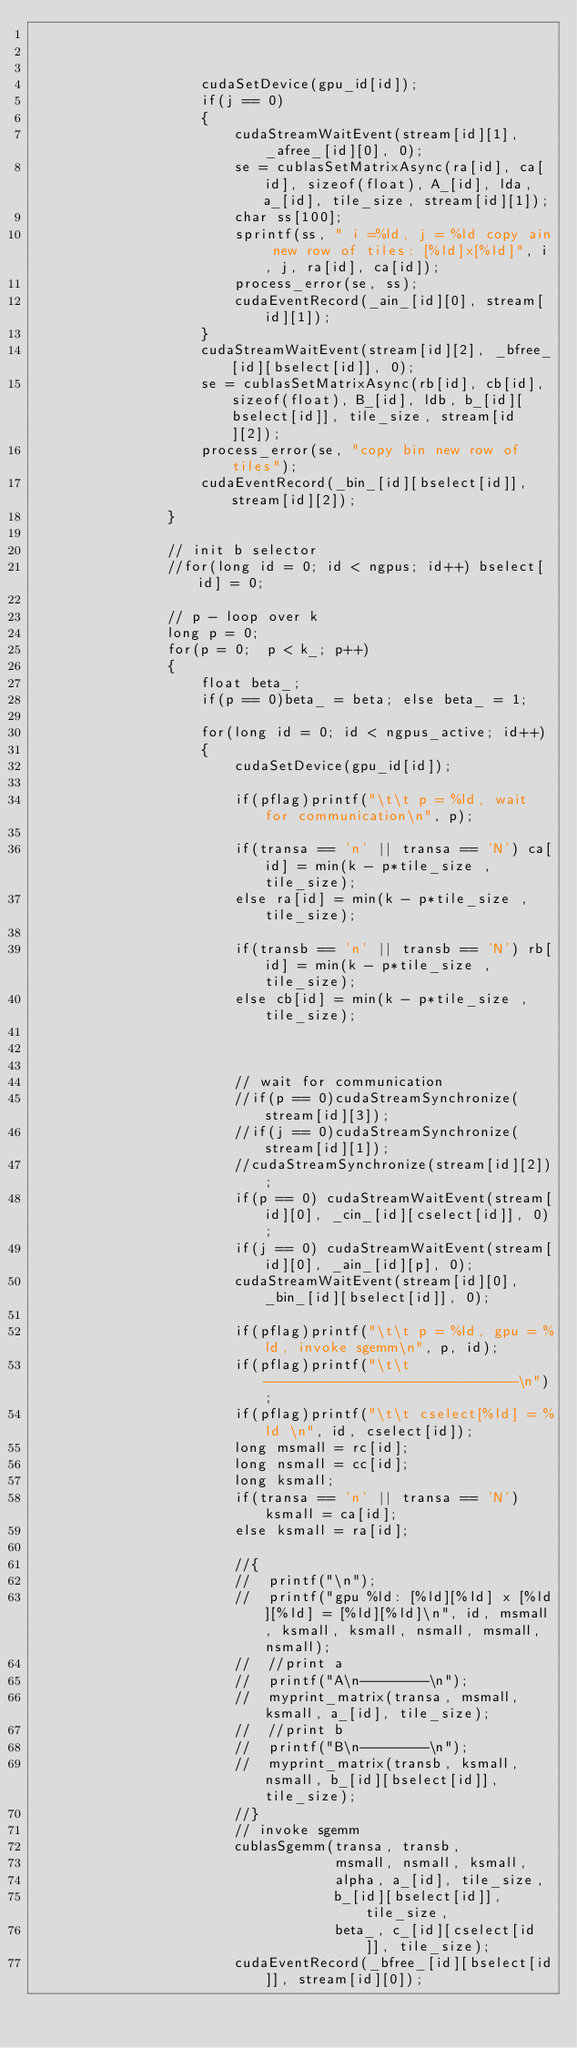<code> <loc_0><loc_0><loc_500><loc_500><_Cuda_>


					cudaSetDevice(gpu_id[id]);
					if(j == 0)
					{
						cudaStreamWaitEvent(stream[id][1], _afree_[id][0], 0);
						se = cublasSetMatrixAsync(ra[id], ca[id], sizeof(float), A_[id], lda, a_[id], tile_size, stream[id][1]);
						char ss[100];
						sprintf(ss, " i =%ld, j = %ld copy ain new row of tiles: [%ld]x[%ld]", i, j, ra[id], ca[id]);
						process_error(se, ss);
						cudaEventRecord(_ain_[id][0], stream[id][1]);
					}
					cudaStreamWaitEvent(stream[id][2], _bfree_[id][bselect[id]], 0);
					se = cublasSetMatrixAsync(rb[id], cb[id], sizeof(float), B_[id], ldb, b_[id][bselect[id]], tile_size, stream[id][2]);
					process_error(se, "copy bin new row of tiles");
					cudaEventRecord(_bin_[id][bselect[id]], stream[id][2]);
				}

				// init b selector
				//for(long id = 0; id < ngpus; id++) bselect[id] = 0;

				// p - loop over k
				long p = 0;
				for(p = 0;  p < k_; p++)
				{
					float beta_;
					if(p == 0)beta_ = beta; else beta_ = 1;

					for(long id = 0; id < ngpus_active; id++)
					{
						cudaSetDevice(gpu_id[id]);

						if(pflag)printf("\t\t p = %ld, wait for communication\n", p);

						if(transa == 'n' || transa == 'N') ca[id] = min(k - p*tile_size , tile_size);
						else ra[id] = min(k - p*tile_size , tile_size);

						if(transb == 'n' || transb == 'N') rb[id] = min(k - p*tile_size , tile_size);
						else cb[id] = min(k - p*tile_size , tile_size);



						// wait for communication
						//if(p == 0)cudaStreamSynchronize(stream[id][3]);
						//if(j == 0)cudaStreamSynchronize(stream[id][1]);
						//cudaStreamSynchronize(stream[id][2]);
						if(p == 0) cudaStreamWaitEvent(stream[id][0], _cin_[id][cselect[id]], 0);
						if(j == 0) cudaStreamWaitEvent(stream[id][0], _ain_[id][p], 0);
						cudaStreamWaitEvent(stream[id][0], _bin_[id][bselect[id]], 0);

						if(pflag)printf("\t\t p = %ld, gpu = %ld, invoke sgemm\n", p, id);
						if(pflag)printf("\t\t ------------------------------\n");
						if(pflag)printf("\t\t cselect[%ld] = %ld \n", id, cselect[id]);
						long msmall = rc[id];
						long nsmall = cc[id];
						long ksmall;
						if(transa == 'n' || transa == 'N') ksmall = ca[id];
						else ksmall = ra[id];

						//{
						//	printf("\n");
						//	printf("gpu %ld: [%ld][%ld] x [%ld][%ld] = [%ld][%ld]\n", id, msmall, ksmall, ksmall, nsmall, msmall, nsmall);
						//	//print a
						//	printf("A\n--------\n");
						//	myprint_matrix(transa, msmall, ksmall, a_[id], tile_size);
						//	//print b
						//	printf("B\n--------\n");
						//	myprint_matrix(transb, ksmall, nsmall, b_[id][bselect[id]], tile_size);
						//}
						// invoke sgemm
						cublasSgemm(transa, transb,
									msmall, nsmall, ksmall,
									alpha, a_[id], tile_size,
									b_[id][bselect[id]], tile_size,
									beta_, c_[id][cselect[id]], tile_size);
						cudaEventRecord(_bfree_[id][bselect[id]], stream[id][0]);</code> 